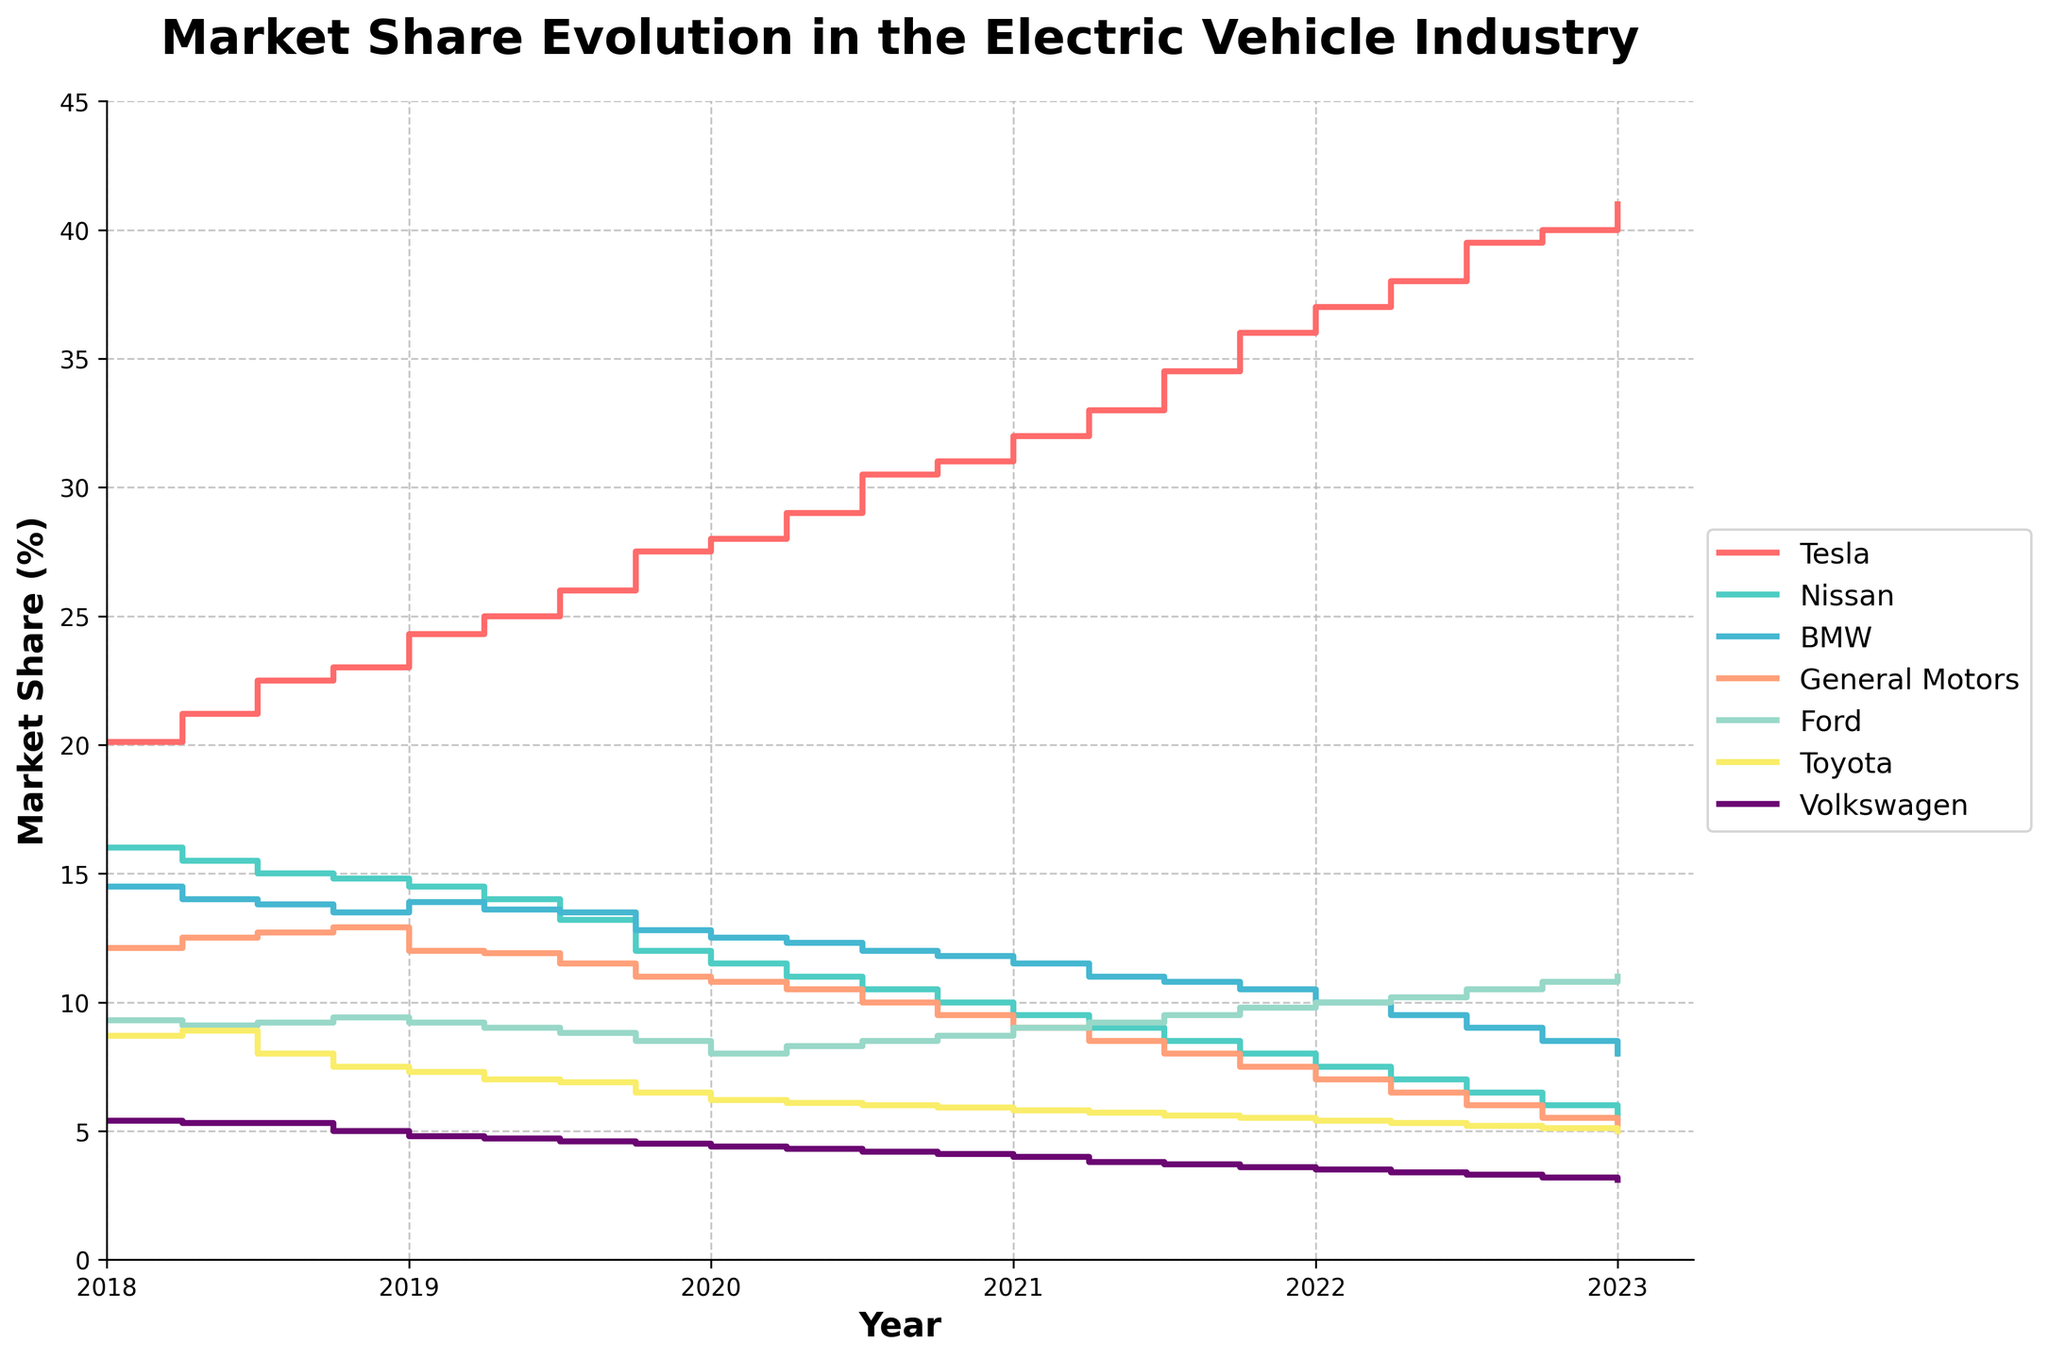What is the title of the plot? The title of the plot can be found at the top of the figure. It indicates what the plot is about.
Answer: Market Share Evolution in the Electric Vehicle Industry Which manufacturer had the highest market share in 2021 Q4? Identify the data points for each manufacturer in 2021 Q4 and compare their values. The highest value will indicate the manufacturer with the highest market share.
Answer: Tesla How did Tesla's market share change from 2018 Q1 to 2023 Q1? Look at Tesla's market share at the beginning (2018 Q1) and at the end (2023 Q1). Subtract the initial value from the final value to find the change.
Answer: Increased by 20.9% Which period shows the greatest decrease in market share for Nissan? Look at Nissan's market share across all quarters. Identify the period where the difference between consecutive data points is the largest negative value.
Answer: 2019 Q1 to 2023 Q1 What is the market share difference between BMW and General Motors in 2022 Q2? Find the market shares for BMW and General Motors in 2022 Q2. Subtract the smaller value from the larger value to find the difference.
Answer: 3.0% Which manufacturer had the second-highest market share in 2019 Q3? Rank the market shares for all manufacturers in 2019 Q3 and find the second-largest one.
Answer: Nissan How did Ford's market share trend from 2018 to 2023? Look at the trend of Ford's market share from 2018 to 2023 across all quarters. Describe whether it generally increased, decreased, or remained stable.
Answer: Increased In which quarter did Toyota's market share drop below 6% for the first time? Review Toyota's market share data and identify the first quarter where it falls below 6%.
Answer: 2020 Q4 Which manufacturer has the most stable market share trend over the years? Compare the market share trends of all manufacturers to identify which one has the least fluctuation.
Answer: Volkswagen Which two manufacturers had relatively close market shares in 2020 Q2? Identify the market shares of all manufacturers in 2020 Q2 and look for two manufacturers with values close to each other.
Answer: BMW and General Motors 